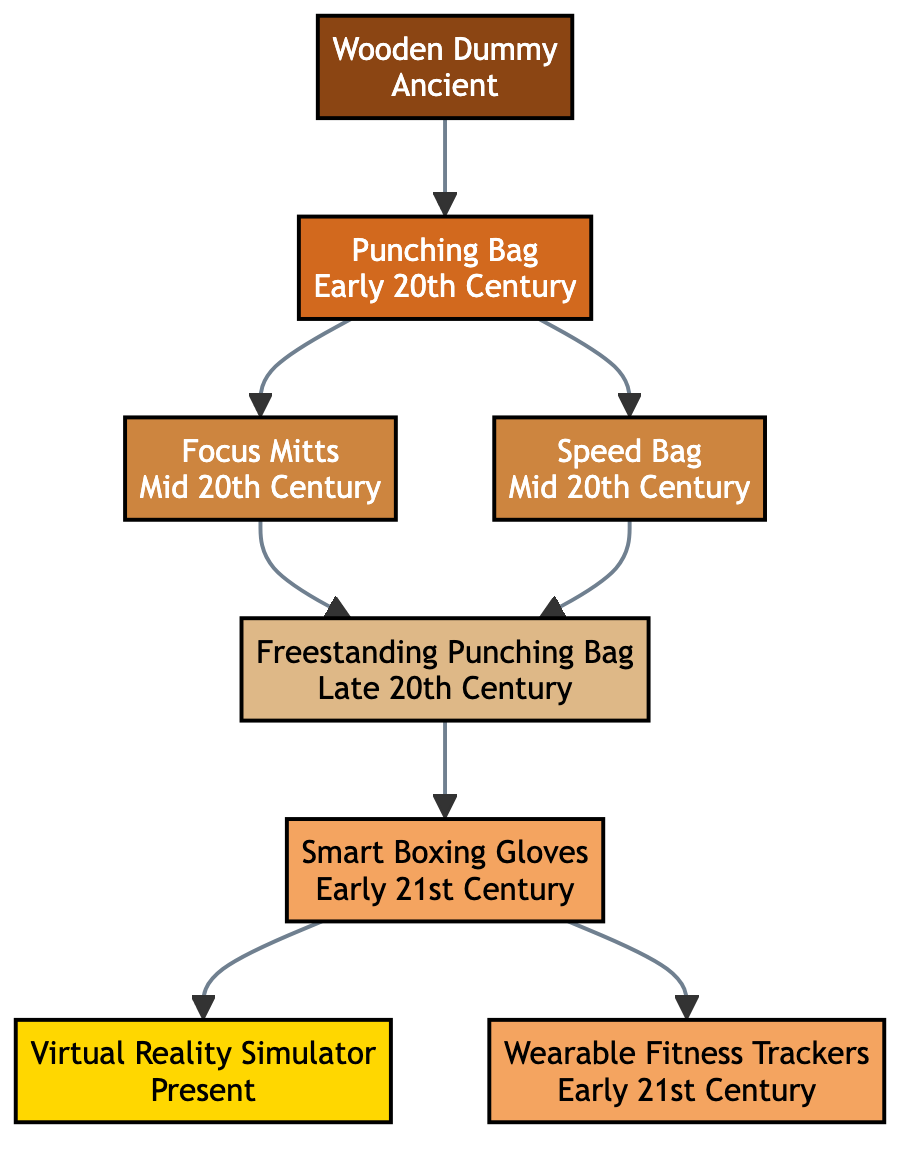What is the earliest training tool depicted in the diagram? The diagram shows a family tree starting with the "Wooden Dummy," which dates back to the Ancient period, making it the earliest tool in the evolution of training tools in martial arts.
Answer: Wooden Dummy How many different training tools are represented in the diagram? The diagram lists a total of eight training tools, each corresponding to a specific time period in martial arts history.
Answer: Eight Which training tool was developed in the Late 20th Century? Referring to the time periods noted in the diagram, the "Freestanding Punching Bag" is identified as the tool developed during the Late 20th Century.
Answer: Freestanding Punching Bag Which tools were created in the Early 21st Century? The diagram highlights two tools from the Early 21st Century: "Smart Boxing Gloves" and "Wearable Fitness Trackers," both of which are contemporary advancements in training technology.
Answer: Smart Boxing Gloves, Wearable Fitness Trackers What training tool follows the "Punching Bag" in the diagram? Looking at the flow of the diagram, the "Focus Mitts" and "Speed Bag" both stem from the "Punching Bag," indicating they are both direct successors.
Answer: Focus Mitts, Speed Bag What is the relationship between "Smart Boxing Gloves" and "Virtual Reality Simulator"? The diagram indicates a sequential relationship where "Smart Boxing Gloves" lead to the "Virtual Reality Simulator," signifying that the former is a precursor to the latter in terms of technological development.
Answer: Sequential Which icon represents the "Speed Bag"? The diagram uses the icon "🥊" to represent the "Speed Bag," visually linking this symbolic representation to the tool within the family tree.
Answer: 🥊 How many nodes connect directly to the "Punching Bag"? The "Punching Bag" has two direct connections in the family tree: one to "Focus Mitts" and another to "Speed Bag." This shows it as a pivotal tool leading to these subsequent developments.
Answer: Two What type of training tool is the "Virtual Reality Simulator"? The "Virtual Reality Simulator," categorized as an immersive training system, represents one of the most advanced technologies in martial arts training as depicted in the diagram.
Answer: Immersive training system 